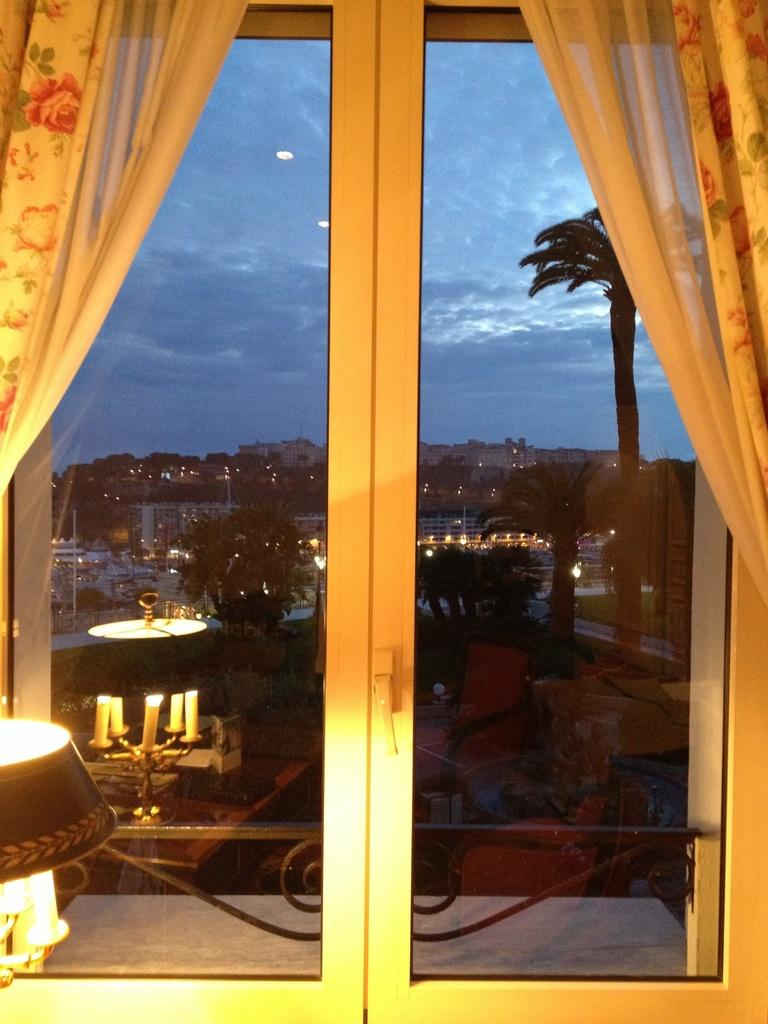What type of view is shown in the image? The image shows an outside view of a city. How is the view being observed? The view is seen through a glass door. What structures can be seen in the image? There are buildings visible in the image. What type of natural elements can be seen in the image? There are trees visible in the image. What type of volleyball game is being played in the image? There is no volleyball game present in the image. What letters can be seen on the buildings in the image? The image does not provide enough detail to determine if there are any letters on the buildings. 